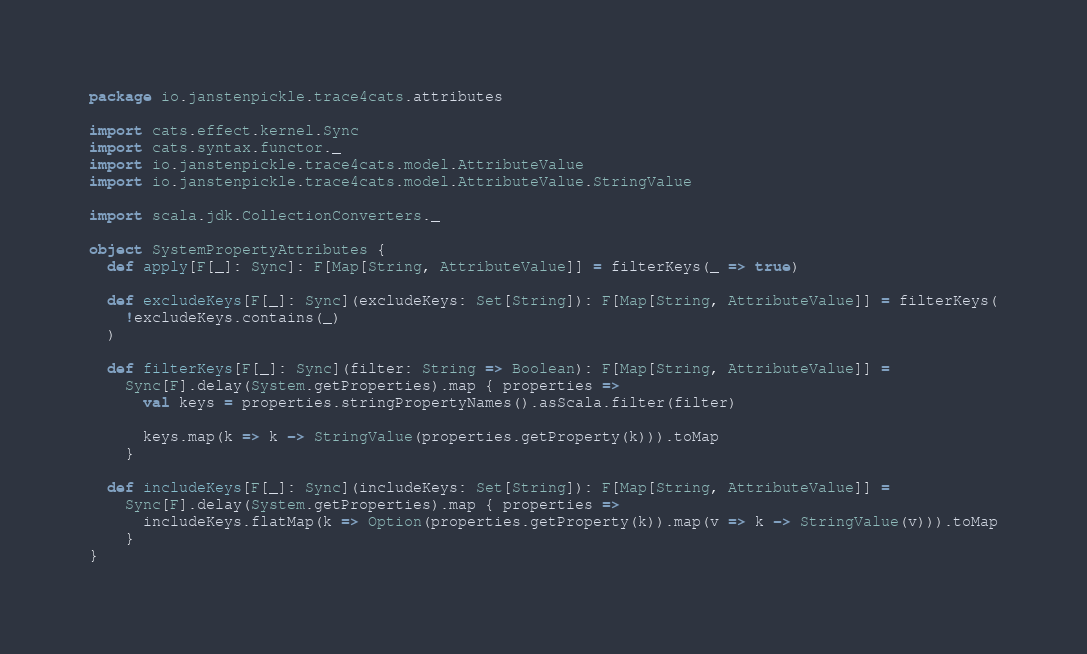Convert code to text. <code><loc_0><loc_0><loc_500><loc_500><_Scala_>package io.janstenpickle.trace4cats.attributes

import cats.effect.kernel.Sync
import cats.syntax.functor._
import io.janstenpickle.trace4cats.model.AttributeValue
import io.janstenpickle.trace4cats.model.AttributeValue.StringValue

import scala.jdk.CollectionConverters._

object SystemPropertyAttributes {
  def apply[F[_]: Sync]: F[Map[String, AttributeValue]] = filterKeys(_ => true)

  def excludeKeys[F[_]: Sync](excludeKeys: Set[String]): F[Map[String, AttributeValue]] = filterKeys(
    !excludeKeys.contains(_)
  )

  def filterKeys[F[_]: Sync](filter: String => Boolean): F[Map[String, AttributeValue]] =
    Sync[F].delay(System.getProperties).map { properties =>
      val keys = properties.stringPropertyNames().asScala.filter(filter)

      keys.map(k => k -> StringValue(properties.getProperty(k))).toMap
    }

  def includeKeys[F[_]: Sync](includeKeys: Set[String]): F[Map[String, AttributeValue]] =
    Sync[F].delay(System.getProperties).map { properties =>
      includeKeys.flatMap(k => Option(properties.getProperty(k)).map(v => k -> StringValue(v))).toMap
    }
}
</code> 